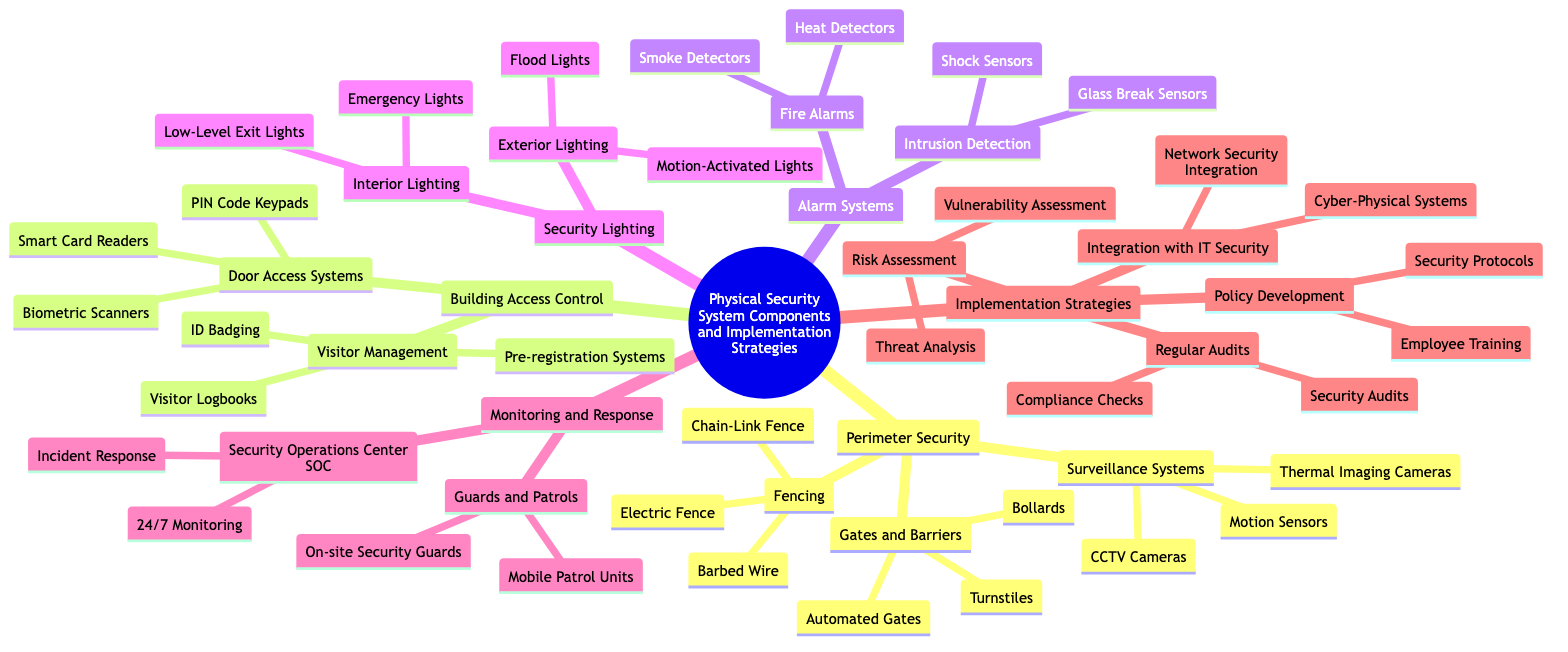What are the three types of fencing mentioned? The three types of fencing are listed under the "Fencing" node in the diagram: Electric Fence, Barbed Wire, and Chain-Link Fence.
Answer: Electric Fence, Barbed Wire, Chain-Link Fence How many components are listed under Building Access Control? The "Building Access Control" node has two main components: Door Access Systems and Visitor Management. Each of these has sub-components, but as a whole, there are two main components.
Answer: 2 Which surveillance system type uses heat detection? The type that uses heat detection is listed under "Surveillance Systems" and is identified as Thermal Imaging Cameras.
Answer: Thermal Imaging Cameras What is included in the Alarm Systems under Fire Alarms? Under "Alarm Systems," the "Fire Alarms" category includes Smoke Detectors and Heat Detectors. Thus, both types are part of this grouping.
Answer: Smoke Detectors, Heat Detectors What is the relationship between Security Operations Center and Incident Response? The "Security Operations Center (SOC)" is a broader component that contains the specific function of "Incident Response." This indicates that incident response is managed by the SOC.
Answer: Security Operations Center contains Incident Response List two strategies under Implementation Strategies related to security improvements. Under "Implementation Strategies," two strategies that are related to security improvements are Risk Assessment and Policy Development. These strategies address different aspects of security enhancement.
Answer: Risk Assessment, Policy Development What do the Motion-Activated Lights fall under in the diagram? Motion-Activated Lights are categorized under "Security Lighting" and specifically fall under "Exterior Lighting" in the diagram.
Answer: Exterior Lighting How many nodes are in the Monitoring and Response section? There are two main nodes under "Monitoring and Response": Security Operations Center (SOC) and Guards and Patrols, making a total of two nodes under this section.
Answer: 2 What is the primary function of the Guards and Patrols component? The primary function of the "Guards and Patrols" component is to provide on-site security and mobile patrol services to ensure the safety of the premises.
Answer: On-site security and mobile patrol services What is the purpose of Regular Audits according to the diagram? Regular Audits are aimed at conducting Security Audits and Compliance Checks, which are essential for maintaining security protocols and integrity.
Answer: Security Audits and Compliance Checks 